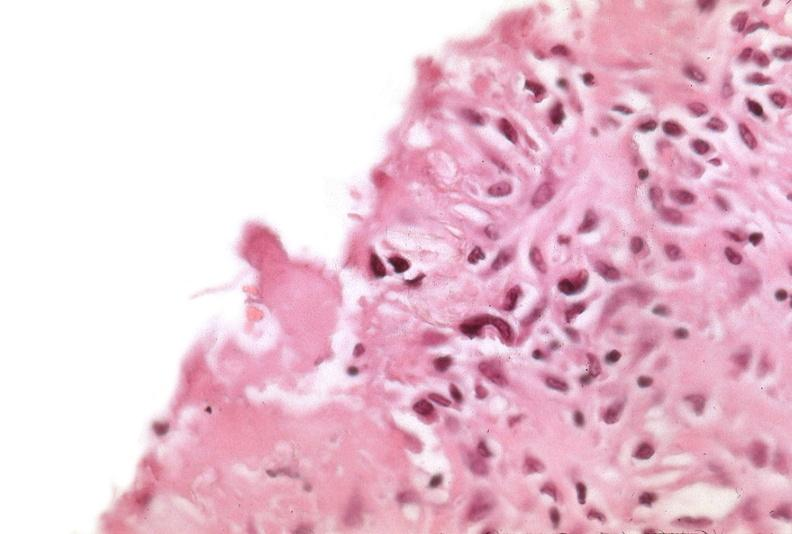what was used to sclerose emphysematous lung, alpha-1 antitrypsin deficiency?
Answer the question using a single word or phrase. Talc 